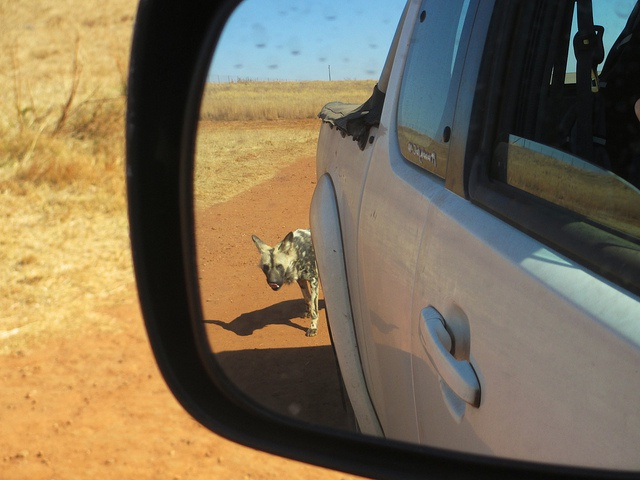Describe the objects in this image and their specific colors. I can see truck in tan, black, and gray tones and dog in tan, gray, and khaki tones in this image. 